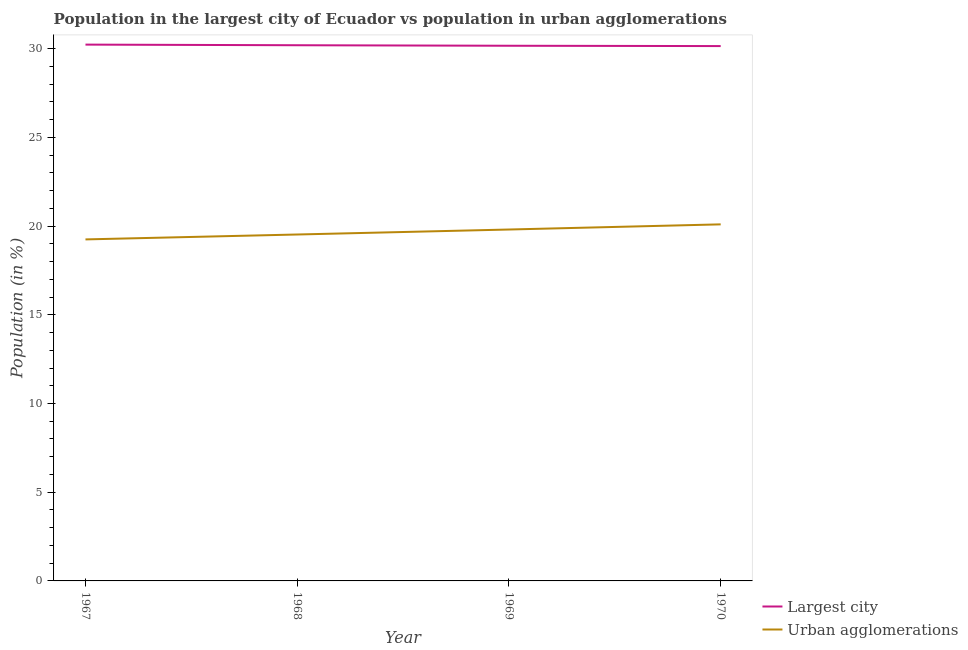How many different coloured lines are there?
Keep it short and to the point. 2. What is the population in the largest city in 1968?
Provide a short and direct response. 30.19. Across all years, what is the maximum population in urban agglomerations?
Ensure brevity in your answer.  20.1. Across all years, what is the minimum population in the largest city?
Make the answer very short. 30.15. In which year was the population in urban agglomerations minimum?
Your answer should be compact. 1967. What is the total population in the largest city in the graph?
Make the answer very short. 120.73. What is the difference between the population in the largest city in 1967 and that in 1969?
Your answer should be very brief. 0.06. What is the difference between the population in the largest city in 1967 and the population in urban agglomerations in 1968?
Ensure brevity in your answer.  10.7. What is the average population in the largest city per year?
Offer a very short reply. 30.18. In the year 1967, what is the difference between the population in urban agglomerations and population in the largest city?
Offer a very short reply. -10.98. What is the ratio of the population in urban agglomerations in 1968 to that in 1969?
Offer a terse response. 0.99. Is the population in urban agglomerations in 1968 less than that in 1969?
Make the answer very short. Yes. What is the difference between the highest and the second highest population in urban agglomerations?
Your response must be concise. 0.29. What is the difference between the highest and the lowest population in urban agglomerations?
Your answer should be very brief. 0.85. In how many years, is the population in urban agglomerations greater than the average population in urban agglomerations taken over all years?
Make the answer very short. 2. Is the sum of the population in the largest city in 1968 and 1970 greater than the maximum population in urban agglomerations across all years?
Provide a succinct answer. Yes. Does the population in the largest city monotonically increase over the years?
Keep it short and to the point. No. Is the population in the largest city strictly greater than the population in urban agglomerations over the years?
Give a very brief answer. Yes. Are the values on the major ticks of Y-axis written in scientific E-notation?
Ensure brevity in your answer.  No. Does the graph contain any zero values?
Provide a short and direct response. No. How many legend labels are there?
Offer a terse response. 2. What is the title of the graph?
Your response must be concise. Population in the largest city of Ecuador vs population in urban agglomerations. Does "External balance on goods" appear as one of the legend labels in the graph?
Your answer should be compact. No. What is the Population (in %) in Largest city in 1967?
Offer a very short reply. 30.23. What is the Population (in %) in Urban agglomerations in 1967?
Keep it short and to the point. 19.25. What is the Population (in %) in Largest city in 1968?
Ensure brevity in your answer.  30.19. What is the Population (in %) in Urban agglomerations in 1968?
Provide a succinct answer. 19.53. What is the Population (in %) of Largest city in 1969?
Give a very brief answer. 30.16. What is the Population (in %) in Urban agglomerations in 1969?
Ensure brevity in your answer.  19.81. What is the Population (in %) in Largest city in 1970?
Make the answer very short. 30.15. What is the Population (in %) of Urban agglomerations in 1970?
Give a very brief answer. 20.1. Across all years, what is the maximum Population (in %) in Largest city?
Your answer should be compact. 30.23. Across all years, what is the maximum Population (in %) of Urban agglomerations?
Offer a terse response. 20.1. Across all years, what is the minimum Population (in %) in Largest city?
Ensure brevity in your answer.  30.15. Across all years, what is the minimum Population (in %) in Urban agglomerations?
Offer a terse response. 19.25. What is the total Population (in %) in Largest city in the graph?
Ensure brevity in your answer.  120.73. What is the total Population (in %) in Urban agglomerations in the graph?
Provide a succinct answer. 78.68. What is the difference between the Population (in %) of Largest city in 1967 and that in 1968?
Offer a very short reply. 0.04. What is the difference between the Population (in %) of Urban agglomerations in 1967 and that in 1968?
Your answer should be compact. -0.28. What is the difference between the Population (in %) in Largest city in 1967 and that in 1969?
Make the answer very short. 0.06. What is the difference between the Population (in %) of Urban agglomerations in 1967 and that in 1969?
Give a very brief answer. -0.56. What is the difference between the Population (in %) in Largest city in 1967 and that in 1970?
Ensure brevity in your answer.  0.08. What is the difference between the Population (in %) in Urban agglomerations in 1967 and that in 1970?
Make the answer very short. -0.85. What is the difference between the Population (in %) of Largest city in 1968 and that in 1969?
Provide a succinct answer. 0.03. What is the difference between the Population (in %) in Urban agglomerations in 1968 and that in 1969?
Offer a terse response. -0.28. What is the difference between the Population (in %) in Largest city in 1968 and that in 1970?
Your response must be concise. 0.05. What is the difference between the Population (in %) of Urban agglomerations in 1968 and that in 1970?
Offer a very short reply. -0.57. What is the difference between the Population (in %) in Largest city in 1969 and that in 1970?
Give a very brief answer. 0.02. What is the difference between the Population (in %) in Urban agglomerations in 1969 and that in 1970?
Make the answer very short. -0.29. What is the difference between the Population (in %) of Largest city in 1967 and the Population (in %) of Urban agglomerations in 1968?
Your answer should be very brief. 10.7. What is the difference between the Population (in %) in Largest city in 1967 and the Population (in %) in Urban agglomerations in 1969?
Give a very brief answer. 10.42. What is the difference between the Population (in %) in Largest city in 1967 and the Population (in %) in Urban agglomerations in 1970?
Make the answer very short. 10.13. What is the difference between the Population (in %) in Largest city in 1968 and the Population (in %) in Urban agglomerations in 1969?
Provide a short and direct response. 10.39. What is the difference between the Population (in %) of Largest city in 1968 and the Population (in %) of Urban agglomerations in 1970?
Offer a very short reply. 10.1. What is the difference between the Population (in %) in Largest city in 1969 and the Population (in %) in Urban agglomerations in 1970?
Your answer should be compact. 10.07. What is the average Population (in %) of Largest city per year?
Your answer should be very brief. 30.18. What is the average Population (in %) of Urban agglomerations per year?
Make the answer very short. 19.67. In the year 1967, what is the difference between the Population (in %) of Largest city and Population (in %) of Urban agglomerations?
Provide a succinct answer. 10.98. In the year 1968, what is the difference between the Population (in %) of Largest city and Population (in %) of Urban agglomerations?
Provide a short and direct response. 10.67. In the year 1969, what is the difference between the Population (in %) in Largest city and Population (in %) in Urban agglomerations?
Give a very brief answer. 10.36. In the year 1970, what is the difference between the Population (in %) in Largest city and Population (in %) in Urban agglomerations?
Provide a succinct answer. 10.05. What is the ratio of the Population (in %) in Largest city in 1967 to that in 1968?
Offer a very short reply. 1. What is the ratio of the Population (in %) of Urban agglomerations in 1967 to that in 1968?
Give a very brief answer. 0.99. What is the ratio of the Population (in %) of Urban agglomerations in 1967 to that in 1969?
Keep it short and to the point. 0.97. What is the ratio of the Population (in %) of Largest city in 1967 to that in 1970?
Your response must be concise. 1. What is the ratio of the Population (in %) of Urban agglomerations in 1967 to that in 1970?
Ensure brevity in your answer.  0.96. What is the ratio of the Population (in %) of Urban agglomerations in 1968 to that in 1969?
Ensure brevity in your answer.  0.99. What is the ratio of the Population (in %) in Urban agglomerations in 1968 to that in 1970?
Give a very brief answer. 0.97. What is the ratio of the Population (in %) in Largest city in 1969 to that in 1970?
Your response must be concise. 1. What is the ratio of the Population (in %) in Urban agglomerations in 1969 to that in 1970?
Your answer should be compact. 0.99. What is the difference between the highest and the second highest Population (in %) in Largest city?
Provide a succinct answer. 0.04. What is the difference between the highest and the second highest Population (in %) in Urban agglomerations?
Offer a very short reply. 0.29. What is the difference between the highest and the lowest Population (in %) in Largest city?
Offer a terse response. 0.08. What is the difference between the highest and the lowest Population (in %) of Urban agglomerations?
Provide a short and direct response. 0.85. 